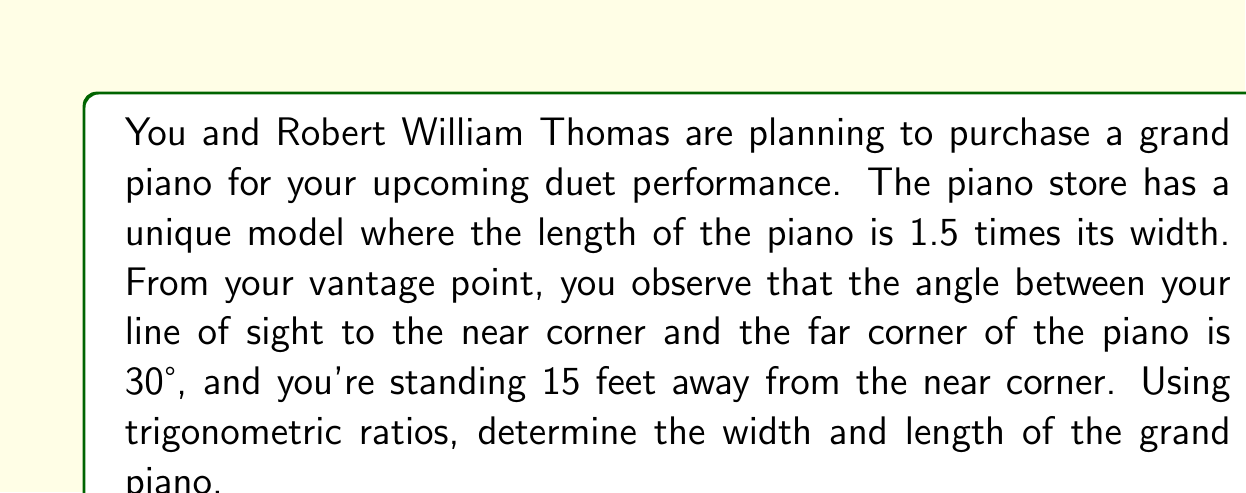Can you answer this question? Let's approach this step-by-step:

1) Let's define our variables:
   $w$ = width of the piano
   $l$ = length of the piano
   $d$ = distance from you to the far corner of the piano

2) We know that $l = 1.5w$

3) We can draw a right triangle where:
   - The shortest side is your distance from the near corner (15 feet)
   - The longest side is your distance to the far corner ($d$)
   - The remaining side is the length of the piano ($l$)

4) Using the tangent ratio in this triangle:

   $$\tan 30° = \frac{l}{15}$$

5) We know that $\tan 30° = \frac{1}{\sqrt{3}}$, so:

   $$\frac{1}{\sqrt{3}} = \frac{l}{15}$$

6) Cross multiply:

   $$15 = l\sqrt{3}$$

7) Divide both sides by $\sqrt{3}$:

   $$\frac{15}{\sqrt{3}} = l$$

8) Simplify:

   $$l = 5\sqrt{3} \approx 8.66 \text{ feet}$$

9) Remember that $l = 1.5w$, so:

   $$5\sqrt{3} = 1.5w$$

10) Solve for $w$:

    $$w = \frac{5\sqrt{3}}{1.5} = \frac{10\sqrt{3}}{3} \approx 5.77 \text{ feet}$$

Therefore, the width of the piano is approximately 5.77 feet and the length is approximately 8.66 feet.
Answer: Width: $\frac{10\sqrt{3}}{3} \approx 5.77$ feet
Length: $5\sqrt{3} \approx 8.66$ feet 